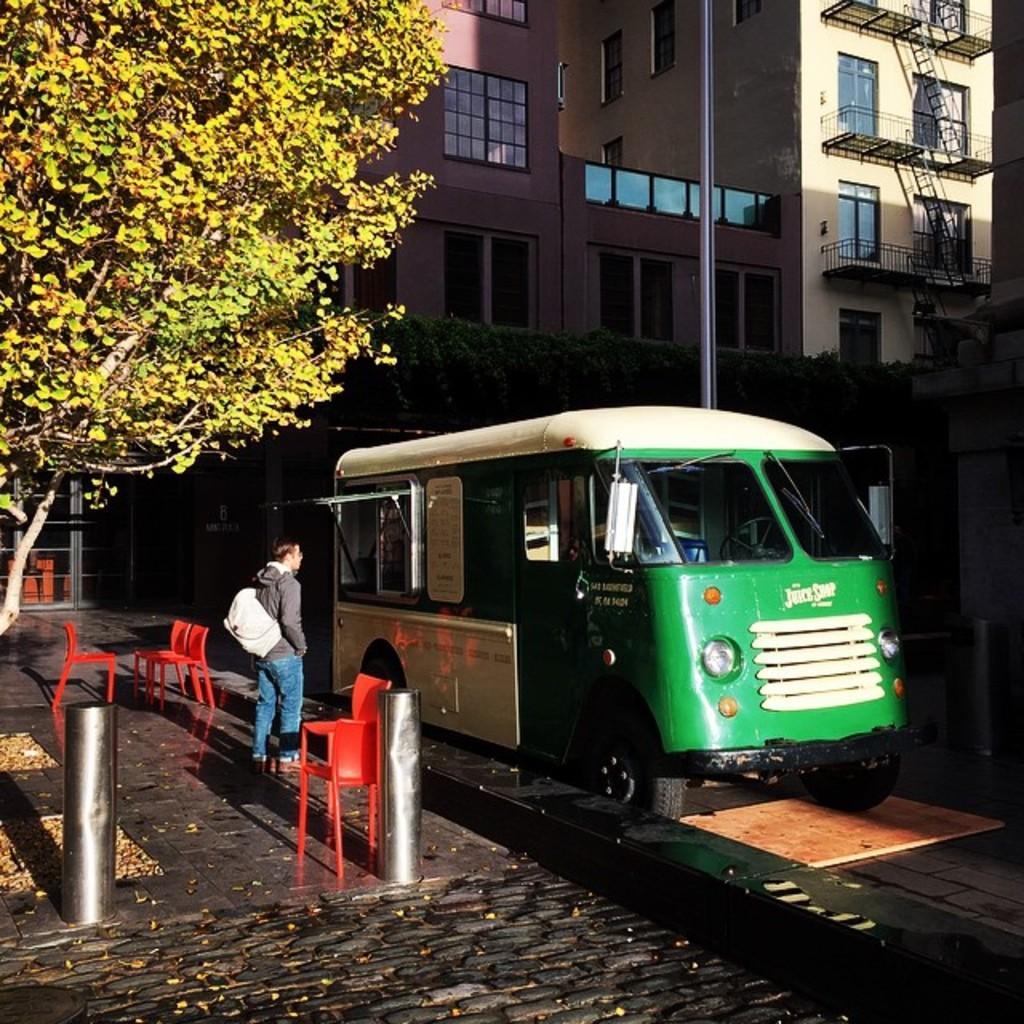Could you give a brief overview of what you see in this image? Left there is a tree. Right there is a minibus and buildings in the middle a man is standing with a bag. 